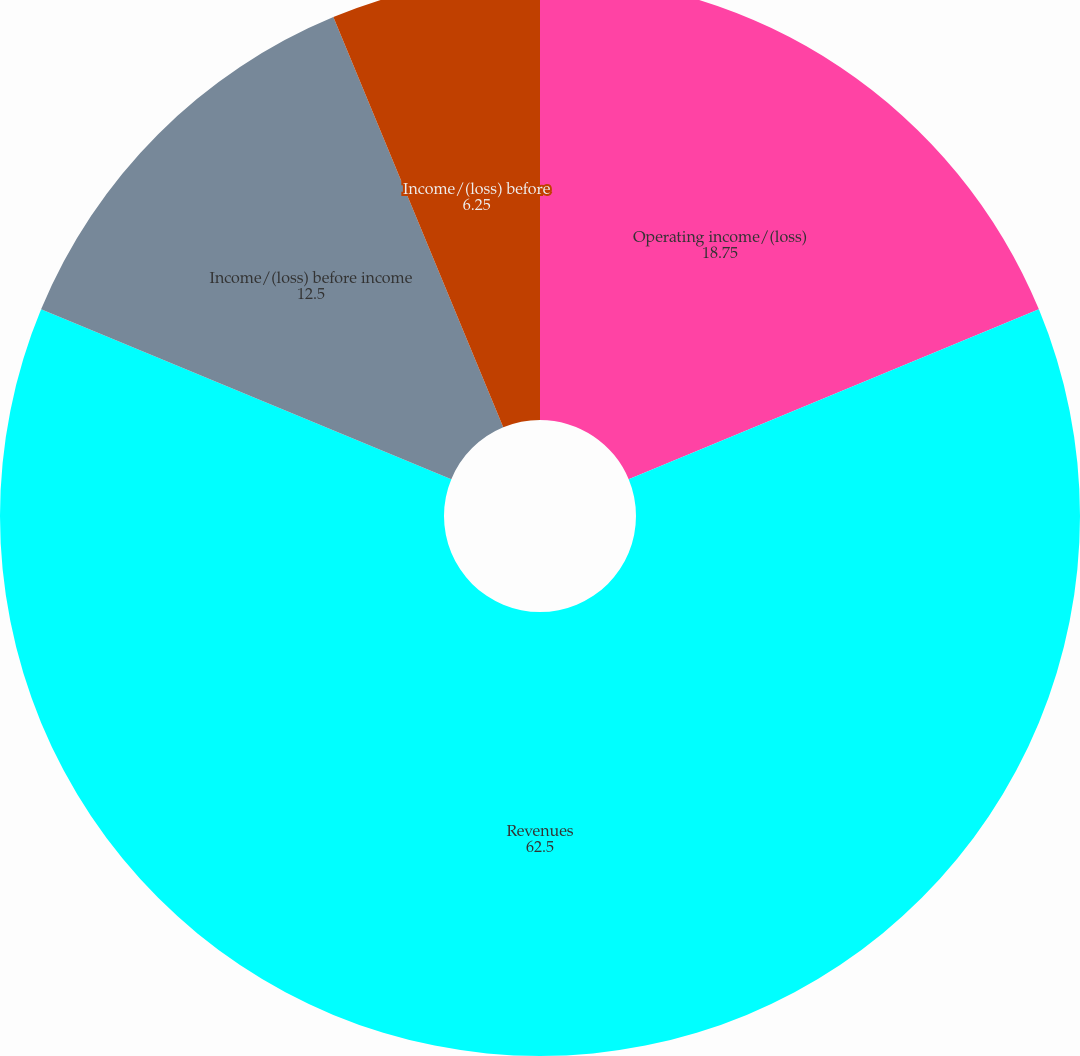Convert chart. <chart><loc_0><loc_0><loc_500><loc_500><pie_chart><fcel>Operating income/(loss)<fcel>Revenues<fcel>Income/(loss) before income<fcel>Income/(loss) before<fcel>Basic<nl><fcel>18.75%<fcel>62.5%<fcel>12.5%<fcel>6.25%<fcel>0.0%<nl></chart> 